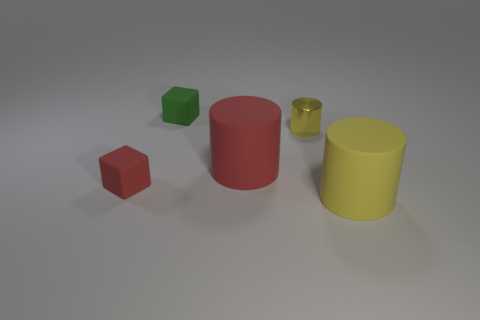Subtract all small yellow cylinders. How many cylinders are left? 2 Subtract all red balls. How many yellow cylinders are left? 2 Add 2 small gray metallic blocks. How many objects exist? 7 Subtract all red cylinders. How many cylinders are left? 2 Subtract all cyan cylinders. Subtract all brown blocks. How many cylinders are left? 3 Subtract 0 gray cubes. How many objects are left? 5 Subtract all blocks. How many objects are left? 3 Subtract all cylinders. Subtract all big yellow matte cylinders. How many objects are left? 1 Add 3 tiny objects. How many tiny objects are left? 6 Add 5 brown rubber things. How many brown rubber things exist? 5 